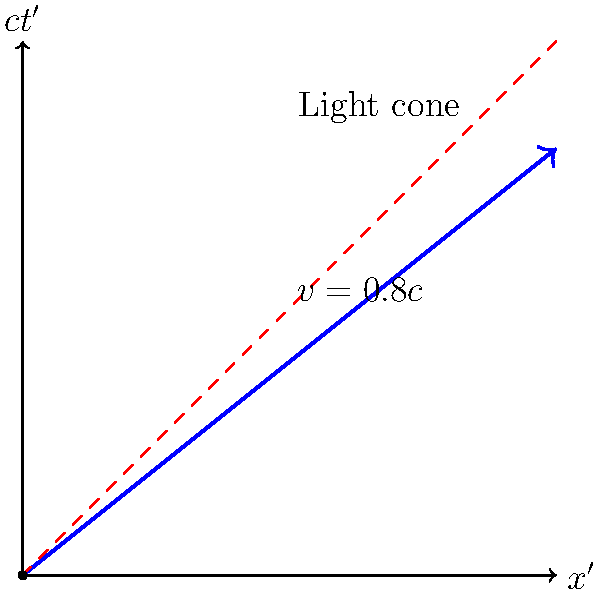In the Lorentz transformation diagram shown, a particle is moving at $v=0.8c$ relative to the observer's frame. Calculate the Lorentz factor $\gamma$ for this particle and explain its significance in the context of special relativity and machine learning applications. To solve this problem, we'll follow these steps:

1) The Lorentz factor $\gamma$ is defined as:

   $$\gamma = \frac{1}{\sqrt{1-\beta^2}}$$

   where $\beta = \frac{v}{c}$

2) We're given that $v = 0.8c$, so $\beta = 0.8$

3) Substituting this into the equation:

   $$\gamma = \frac{1}{\sqrt{1-(0.8)^2}} = \frac{1}{\sqrt{1-0.64}} = \frac{1}{\sqrt{0.36}} = \frac{1}{0.6} = \frac{5}{3} \approx 1.67$$

4) The significance of $\gamma$ in special relativity:
   - It represents the factor by which time dilates and length contracts in the moving frame.
   - It's always greater than or equal to 1, approaching infinity as $v$ approaches $c$.
   - It's a key component in many relativistic formulas, such as for energy ($E = \gamma mc^2$) and momentum ($p = \gamma mv$).

5) In the context of machine learning and data science:
   - The Lorentz transformation and $\gamma$ factor are crucial in high-energy physics simulations, which often use machine learning for data analysis.
   - The hyperbolic geometry of Minkowski spacetime, represented by Lorentz transformations, has analogies in certain neural network architectures and optimization algorithms.
   - Understanding these concepts can aid in developing more accurate models for relativistic systems or in creating novel machine learning architectures inspired by physics principles.
Answer: $\gamma = \frac{5}{3} \approx 1.67$ 